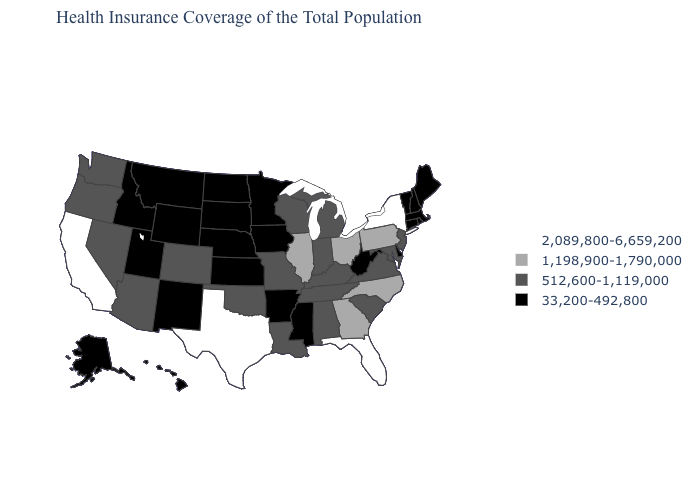Does Delaware have a lower value than Virginia?
Quick response, please. Yes. Which states have the lowest value in the West?
Quick response, please. Alaska, Hawaii, Idaho, Montana, New Mexico, Utah, Wyoming. Does the first symbol in the legend represent the smallest category?
Give a very brief answer. No. Does Illinois have the highest value in the MidWest?
Short answer required. Yes. What is the value of California?
Short answer required. 2,089,800-6,659,200. Does Minnesota have a lower value than Maryland?
Short answer required. Yes. How many symbols are there in the legend?
Give a very brief answer. 4. What is the highest value in the USA?
Write a very short answer. 2,089,800-6,659,200. Which states have the lowest value in the South?
Answer briefly. Arkansas, Delaware, Mississippi, West Virginia. How many symbols are there in the legend?
Be succinct. 4. Which states hav the highest value in the MidWest?
Concise answer only. Illinois, Ohio. Among the states that border Washington , does Idaho have the highest value?
Give a very brief answer. No. Name the states that have a value in the range 512,600-1,119,000?
Give a very brief answer. Alabama, Arizona, Colorado, Indiana, Kentucky, Louisiana, Maryland, Michigan, Missouri, Nevada, New Jersey, Oklahoma, Oregon, South Carolina, Tennessee, Virginia, Washington, Wisconsin. Does the map have missing data?
Give a very brief answer. No. Among the states that border New Jersey , which have the highest value?
Concise answer only. New York. 